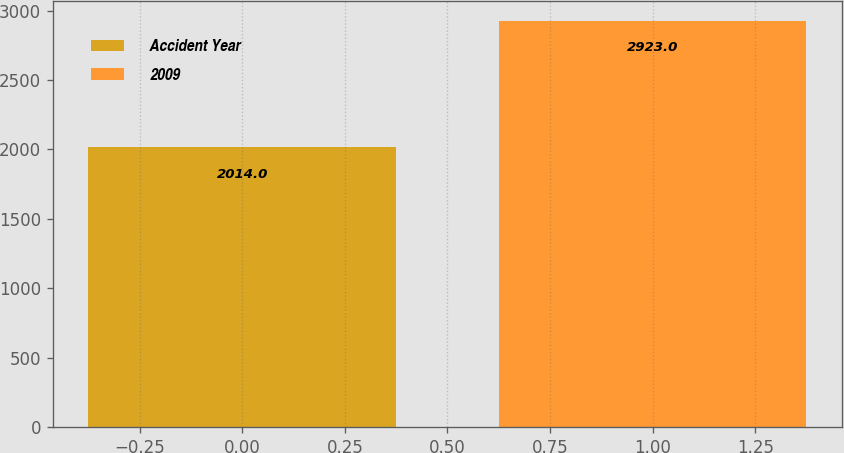Convert chart. <chart><loc_0><loc_0><loc_500><loc_500><bar_chart><fcel>Accident Year<fcel>2009<nl><fcel>2014<fcel>2923<nl></chart> 